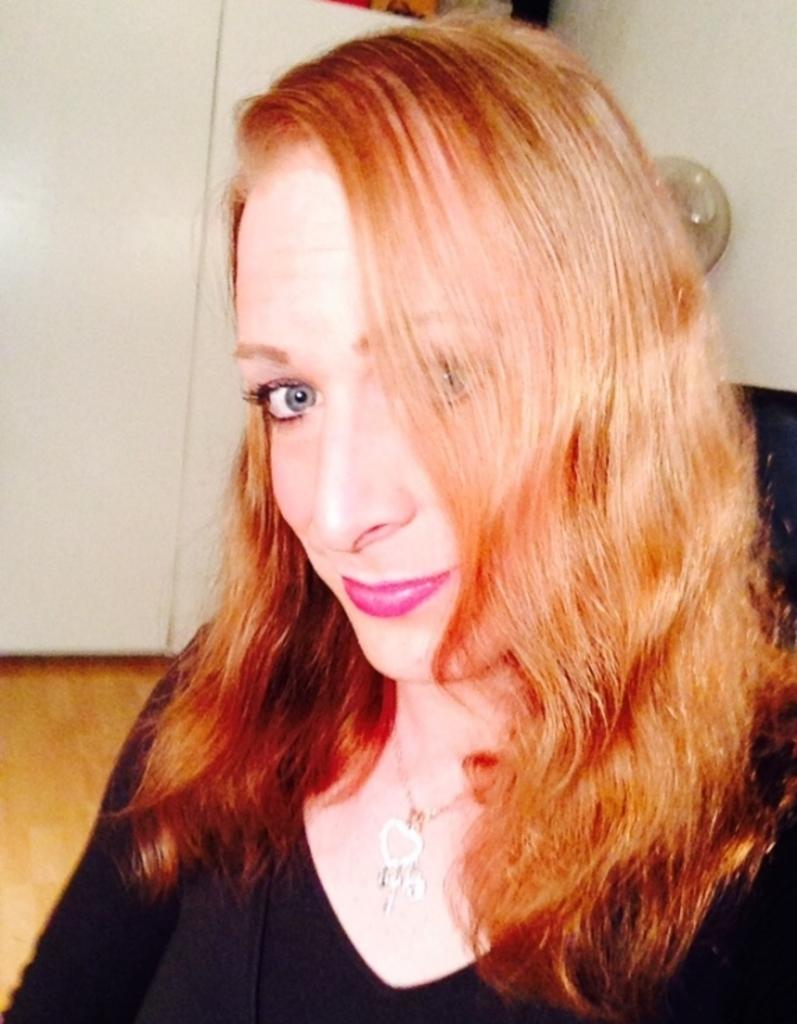Who is the main subject in the foreground of the image? There is a woman in the foreground of the image. What is the woman wearing in the image? The woman is wearing a black T-shirt. What can be seen in the background of the image? There is a white cupboard, the floor, and a wall visible in the background of the image. What type of bear can be seen playing with a bead in the image? There is no bear or bead present in the image; it features a woman in the foreground and various elements in the background. What time of day is depicted in the image? The time of day cannot be determined from the image, as there are no specific clues or indicators present. 